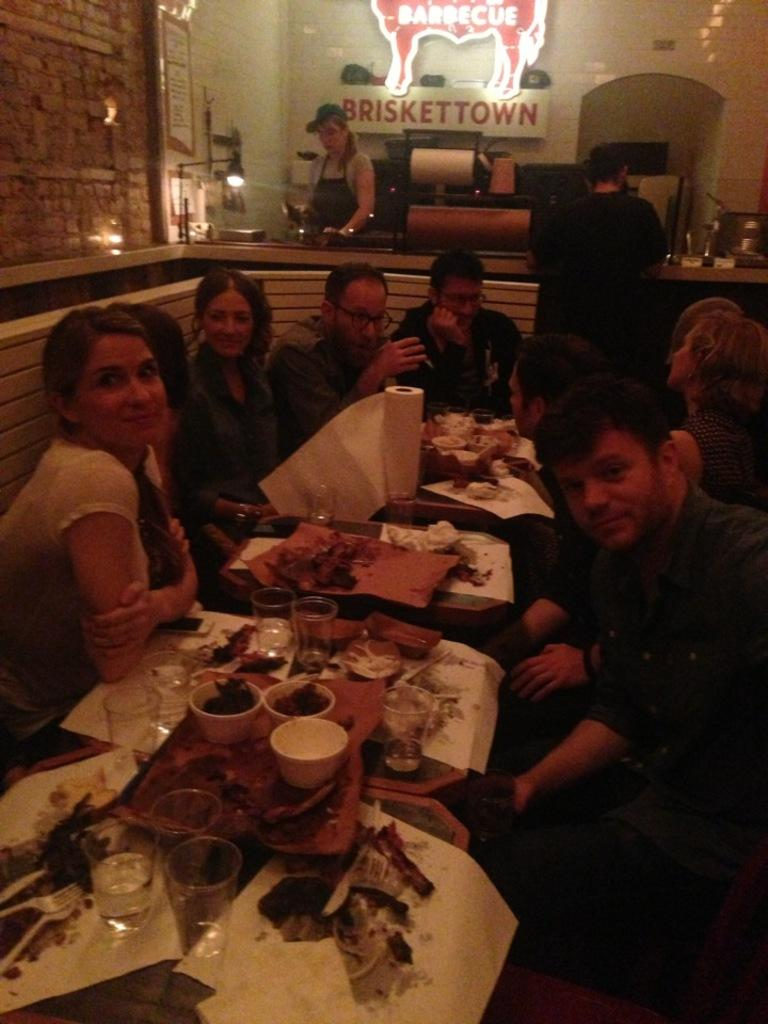What is the main activity of the people in the image? The people in the image are sitting on chairs. What is the primary piece of furniture in the image? There is a table in the image. What items can be seen on the table? A glass, a bowl, spoons, forks, and tissue paper are present on the table. What type of jeans is the flock of birds wearing in the image? There are no birds or jeans present in the image. 